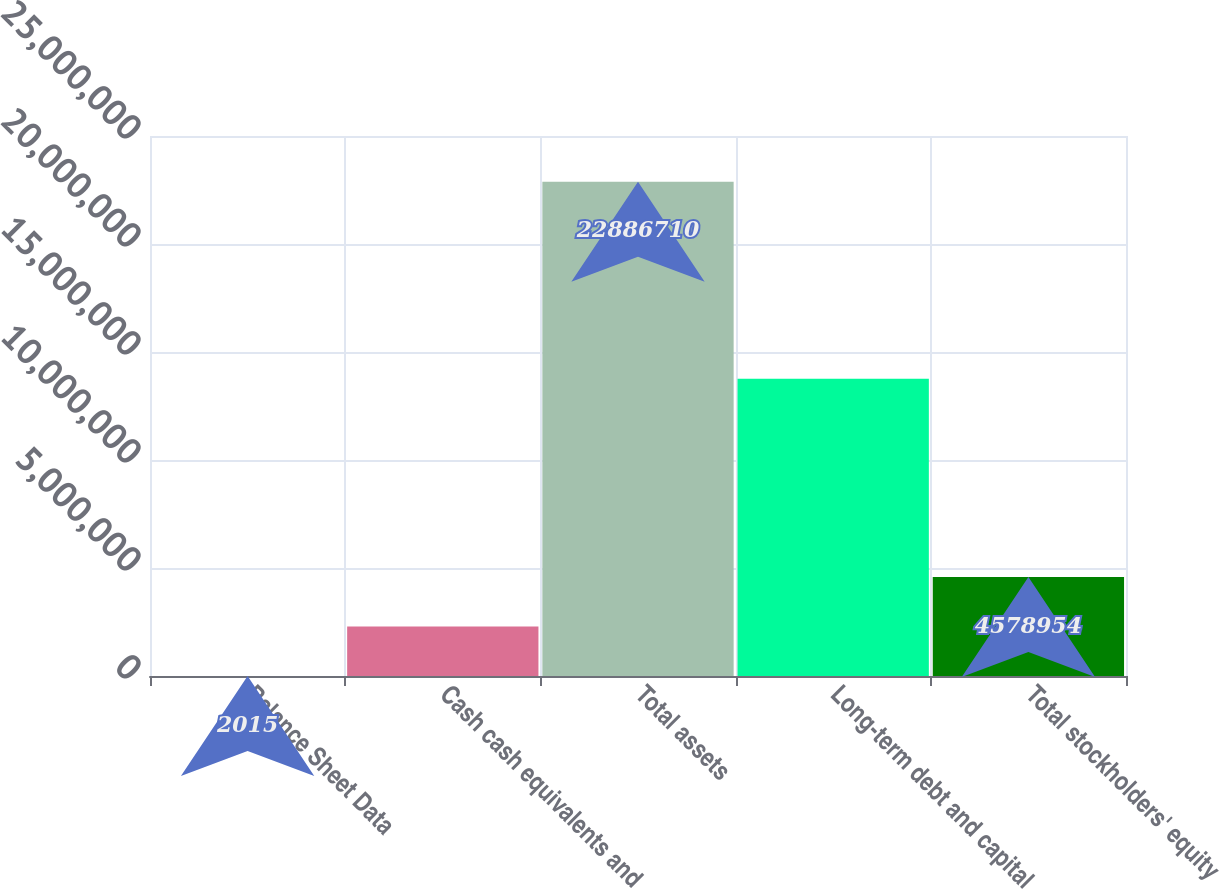Convert chart. <chart><loc_0><loc_0><loc_500><loc_500><bar_chart><fcel>Balance Sheet Data<fcel>Cash cash equivalents and<fcel>Total assets<fcel>Long-term debt and capital<fcel>Total stockholders' equity<nl><fcel>2015<fcel>2.29048e+06<fcel>2.28867e+07<fcel>1.37559e+07<fcel>4.57895e+06<nl></chart> 